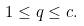<formula> <loc_0><loc_0><loc_500><loc_500>1 \leq q \leq c .</formula> 